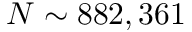<formula> <loc_0><loc_0><loc_500><loc_500>N \sim 8 8 2 , 3 6 1</formula> 